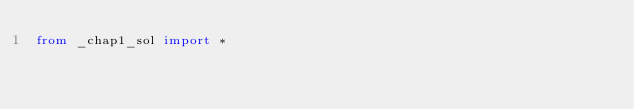Convert code to text. <code><loc_0><loc_0><loc_500><loc_500><_Python_>from _chap1_sol import *
</code> 